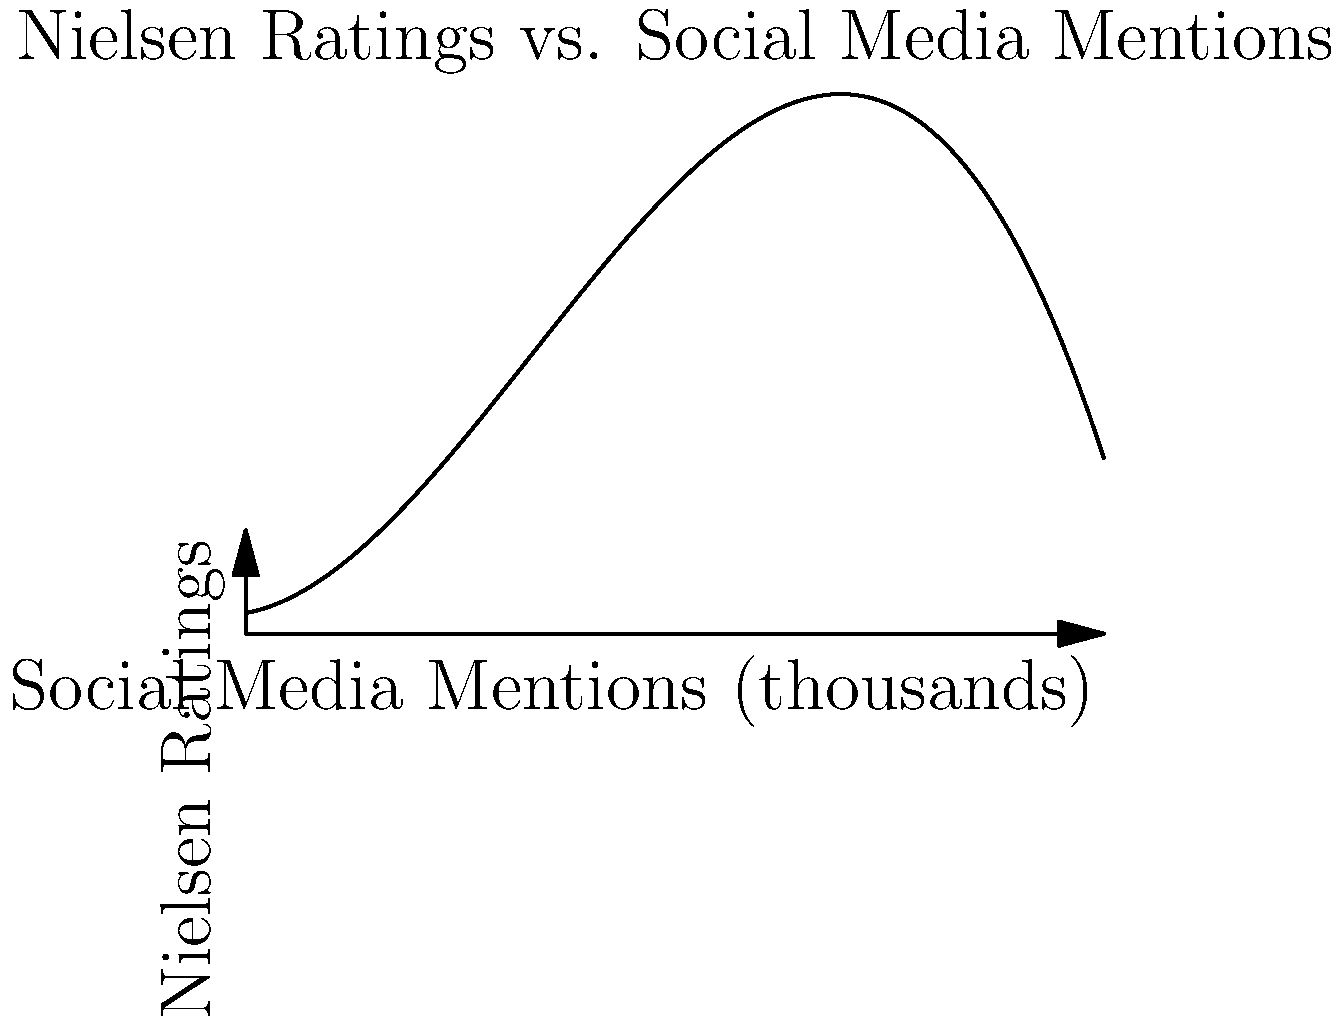Based on the polynomial graph showing the relationship between social media mentions and Nielsen ratings for a fantasy show, at approximately how many thousand social media mentions does the show reach its peak Nielsen rating? To find the peak of the Nielsen ratings, we need to analyze the polynomial graph:

1. The graph represents a cubic function, as evidenced by its shape with one peak and one trough.

2. The peak of the graph represents the maximum Nielsen rating achieved.

3. To find the x-coordinate (number of social media mentions) at the peak, we need to estimate where the slope of the curve changes from positive to negative.

4. Visually examining the graph, we can see that the peak occurs between 15 and 20 thousand social media mentions.

5. More precisely, the peak appears to be closest to 18 thousand mentions.

6. This point represents the optimal number of social media mentions for maximizing Nielsen ratings.

7. After this point, additional social media mentions seem to correlate with a decline in ratings, possibly due to overexposure or audience fatigue.
Answer: Approximately 18 thousand 